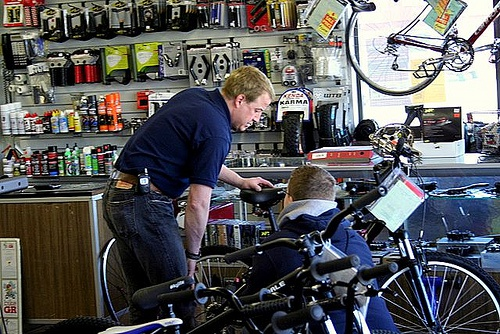Describe the objects in this image and their specific colors. I can see people in gray, black, navy, and darkgray tones, bicycle in gray, black, lightblue, and navy tones, bicycle in gray, white, black, and darkgray tones, people in gray, black, navy, and darkgray tones, and bicycle in gray, black, darkgray, and navy tones in this image. 